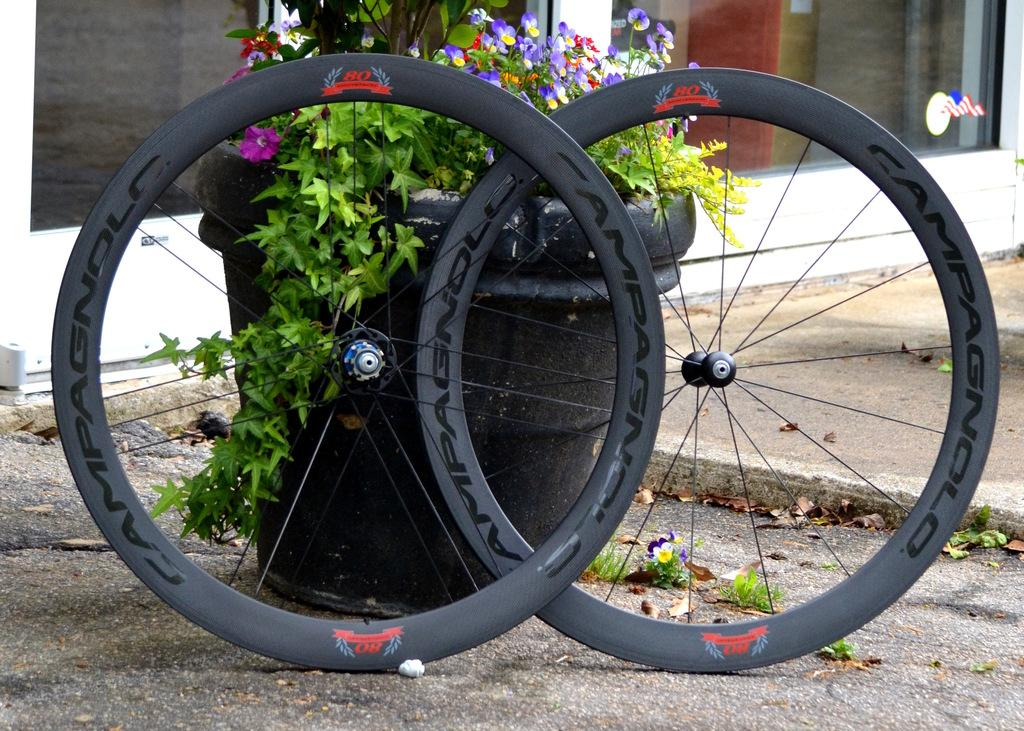What type of objects are in the pots in the image? There are plants in pots in the image. What can be seen on the ground in the image? There are tires placed on the ground in the image. What type of structure is visible in the image? There is a glass window visible on the backside of the image. What is the rabbit's tendency when it sees the tires in the image? There is no rabbit present in the image, so it is not possible to determine its tendency when seeing the tires. 